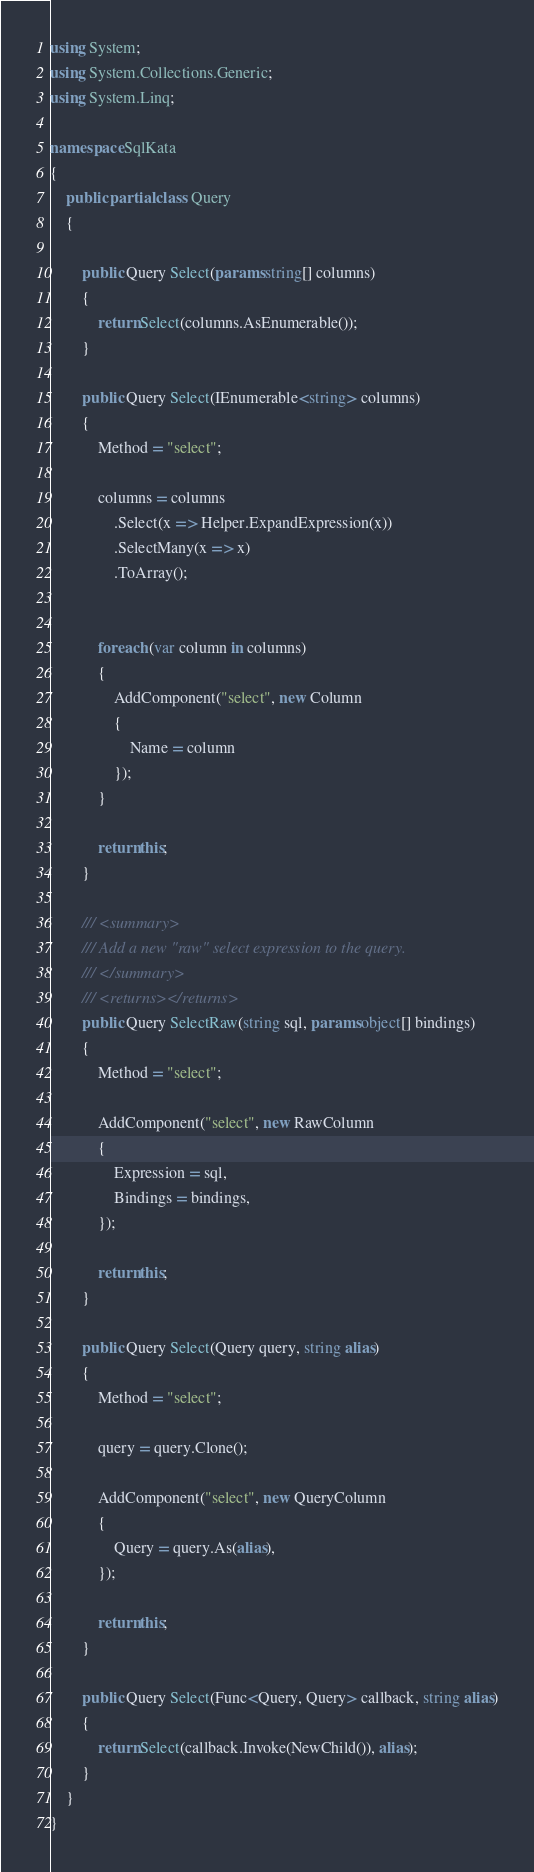Convert code to text. <code><loc_0><loc_0><loc_500><loc_500><_C#_>using System;
using System.Collections.Generic;
using System.Linq;

namespace SqlKata
{
    public partial class Query
    {

        public Query Select(params string[] columns)
        {
            return Select(columns.AsEnumerable());
        }

        public Query Select(IEnumerable<string> columns)
        {
            Method = "select";

            columns = columns
                .Select(x => Helper.ExpandExpression(x))
                .SelectMany(x => x)
                .ToArray();


            foreach (var column in columns)
            {
                AddComponent("select", new Column
                {
                    Name = column
                });
            }

            return this;
        }

        /// <summary>
        /// Add a new "raw" select expression to the query.
        /// </summary>
        /// <returns></returns>
        public Query SelectRaw(string sql, params object[] bindings)
        {
            Method = "select";

            AddComponent("select", new RawColumn
            {
                Expression = sql,
                Bindings = bindings,
            });

            return this;
        }

        public Query Select(Query query, string alias)
        {
            Method = "select";

            query = query.Clone();

            AddComponent("select", new QueryColumn
            {
                Query = query.As(alias),
            });

            return this;
        }

        public Query Select(Func<Query, Query> callback, string alias)
        {
            return Select(callback.Invoke(NewChild()), alias);
        }
    }
}
</code> 